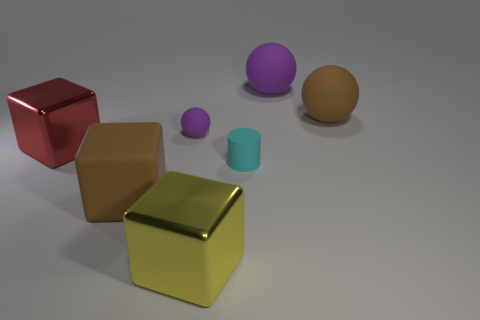What is the light source in this setting and how is it affecting the appearance of the objects? The image depicts a softly lit scene with shadows cast on the right side of the objects, indicating the presence of a light source coming from the left. The gentle lighting creates soft shadows that give the objects a three-dimensional quality and help delineate their shapes. The light source seems diffused, resulting in subtle and smooth shading on the surfaces of the objects, which enhances the textural qualities of each material represented. 